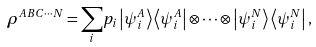Convert formula to latex. <formula><loc_0><loc_0><loc_500><loc_500>\rho ^ { A B C \cdots N } = \underset { i } { \sum } p _ { i } \left | \psi _ { i } ^ { A } \right \rangle \left \langle \psi _ { i } ^ { A } \right | \otimes \cdots \otimes \left | \psi _ { i } ^ { N } \right \rangle \left \langle \psi _ { i } ^ { N } \right | ,</formula> 